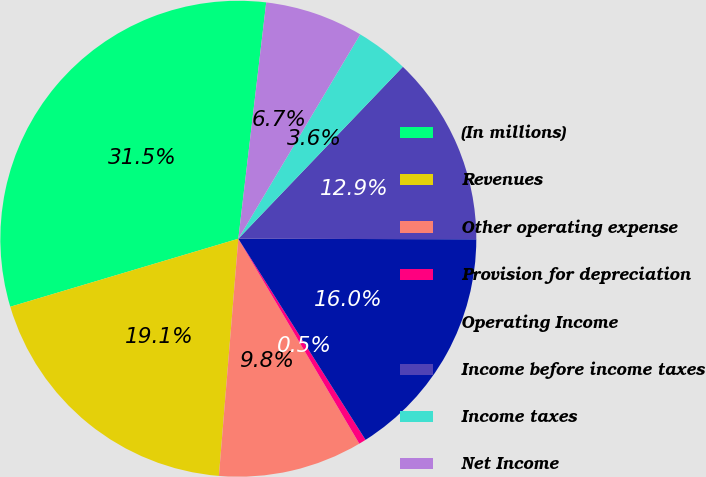<chart> <loc_0><loc_0><loc_500><loc_500><pie_chart><fcel>(In millions)<fcel>Revenues<fcel>Other operating expense<fcel>Provision for depreciation<fcel>Operating Income<fcel>Income before income taxes<fcel>Income taxes<fcel>Net Income<nl><fcel>31.49%<fcel>19.09%<fcel>9.79%<fcel>0.49%<fcel>15.99%<fcel>12.89%<fcel>3.59%<fcel>6.69%<nl></chart> 